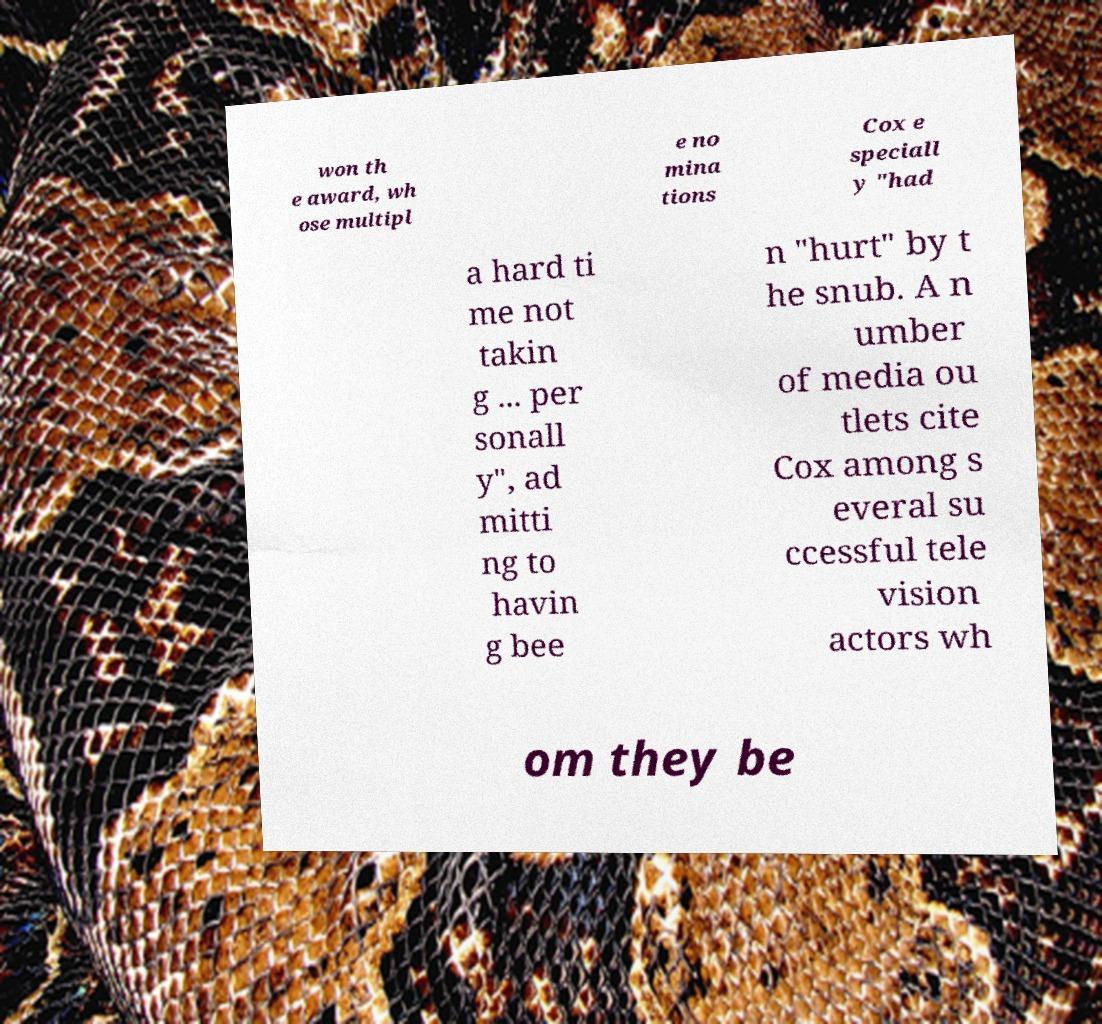Please read and relay the text visible in this image. What does it say? won th e award, wh ose multipl e no mina tions Cox e speciall y "had a hard ti me not takin g ... per sonall y", ad mitti ng to havin g bee n "hurt" by t he snub. A n umber of media ou tlets cite Cox among s everal su ccessful tele vision actors wh om they be 